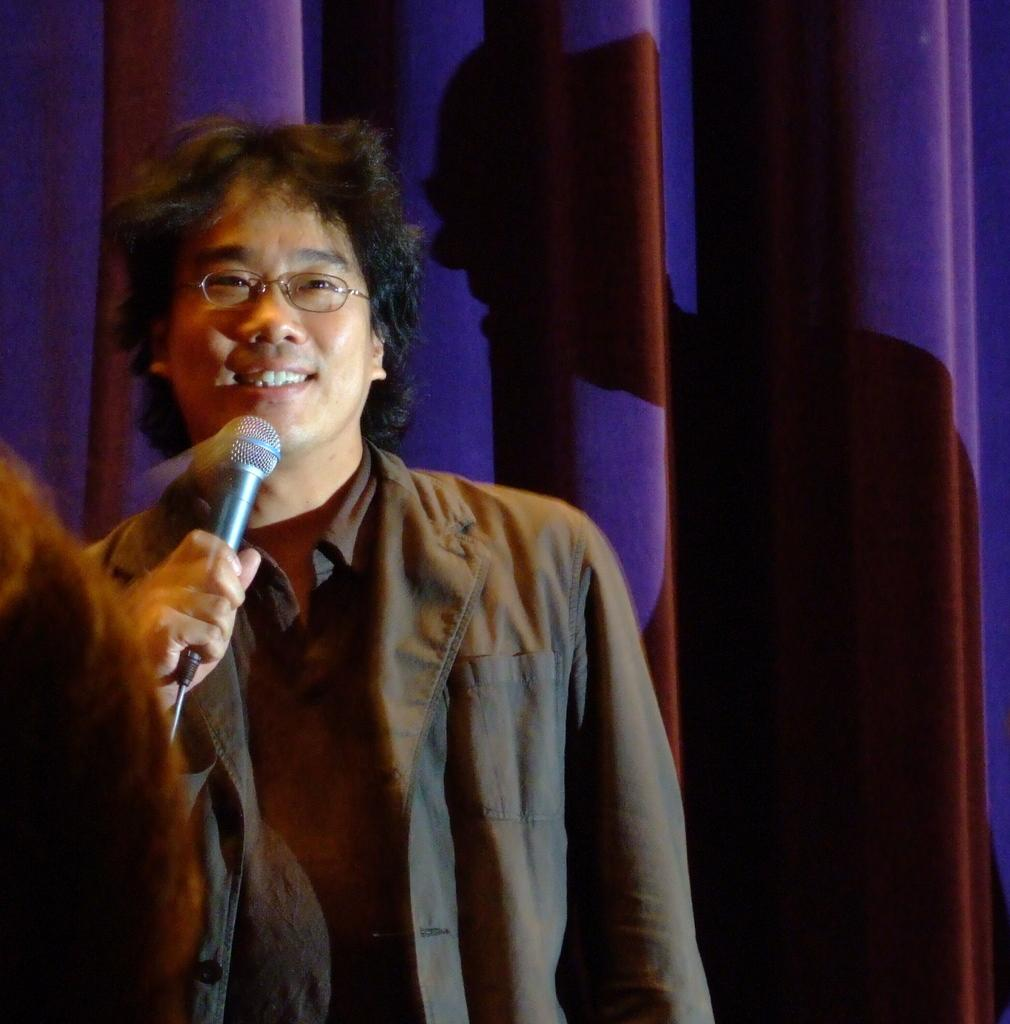What is the main subject of the image? There is a man in the image. What is the man doing in the image? The man is standing and holding a mic in his hand. What is the man's facial expression in the image? The man is smiling in the image. What can be seen in the background of the image? There is a curtain in the background of the image. What type of route is the man holding in his hand in the image? The man is not holding a route in his hand; he is holding a mic. Can you see any roses in the image? There are no roses present in the image. 